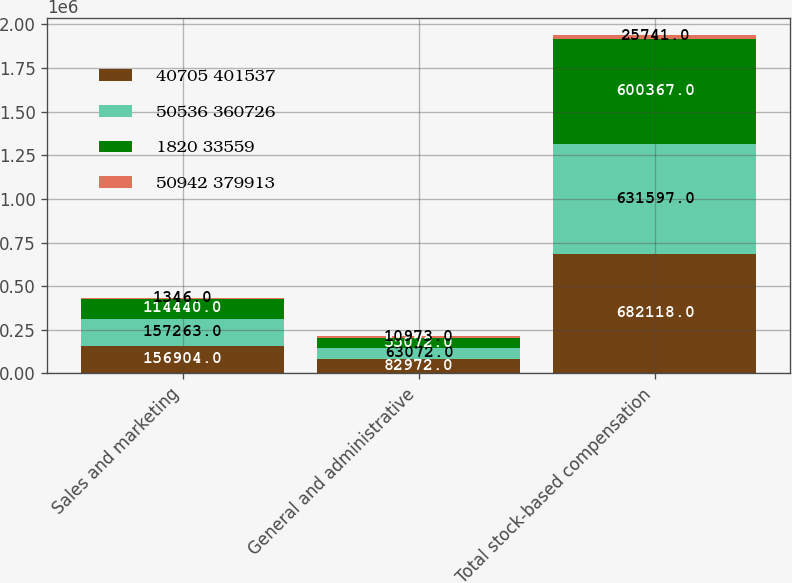Convert chart. <chart><loc_0><loc_0><loc_500><loc_500><stacked_bar_chart><ecel><fcel>Sales and marketing<fcel>General and administrative<fcel>Total stock-based compensation<nl><fcel>40705 401537<fcel>156904<fcel>82972<fcel>682118<nl><fcel>50536 360726<fcel>157263<fcel>63072<fcel>631597<nl><fcel>1820 33559<fcel>114440<fcel>55072<fcel>600367<nl><fcel>50942 379913<fcel>1346<fcel>10973<fcel>25741<nl></chart> 